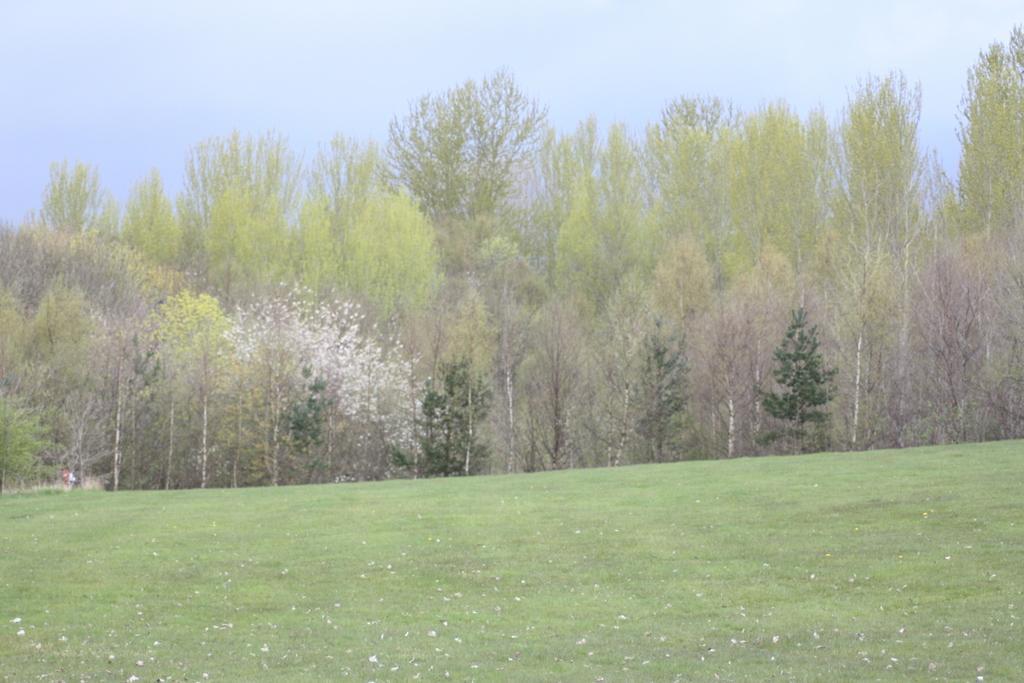Could you give a brief overview of what you see in this image? In the foreground of this image, at the bottom, there is grass land. In the middle, there are trees. At the top, there is the sky. 